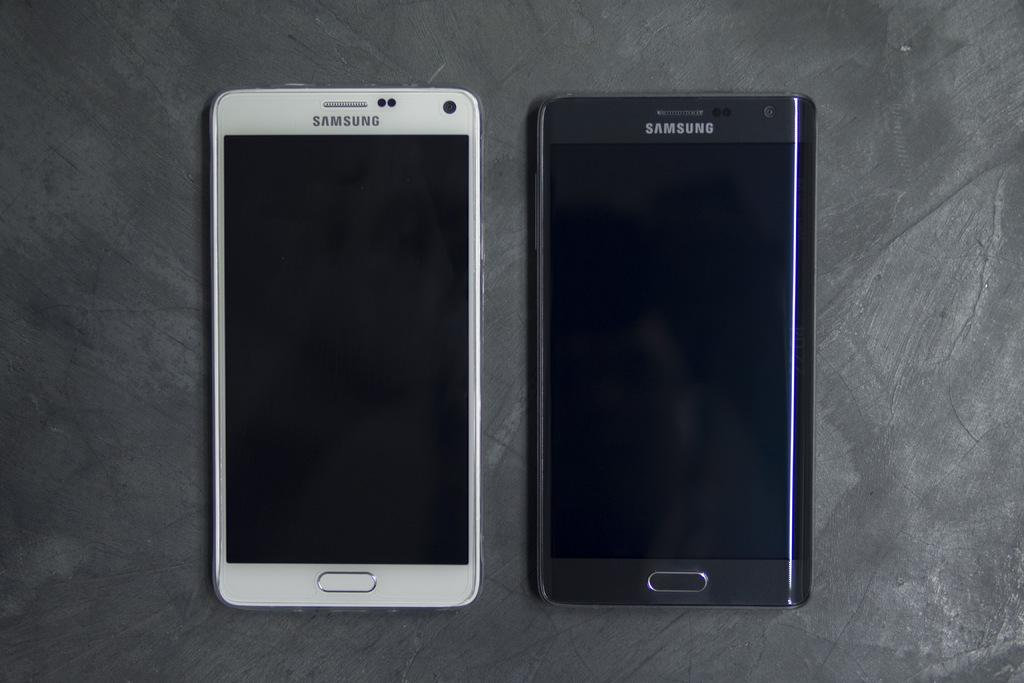<image>
Write a terse but informative summary of the picture. Saumsung smart phones are available in more than one color. 